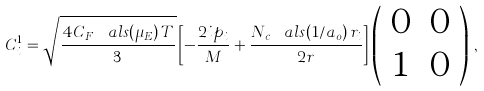<formula> <loc_0><loc_0><loc_500><loc_500>C ^ { 1 } _ { i } = \sqrt { \frac { 4 C _ { F } \, \ a l s ( \mu _ { E } ) \, T } { 3 } } \left [ - \frac { 2 i p _ { i } } { M } + \frac { N _ { c } \, \ a l s ( 1 / a _ { o } ) \, r _ { i } } { 2 r } \right ] \left ( \begin{array} { c c } 0 & 0 \\ 1 & 0 \end{array} \right ) \, ,</formula> 